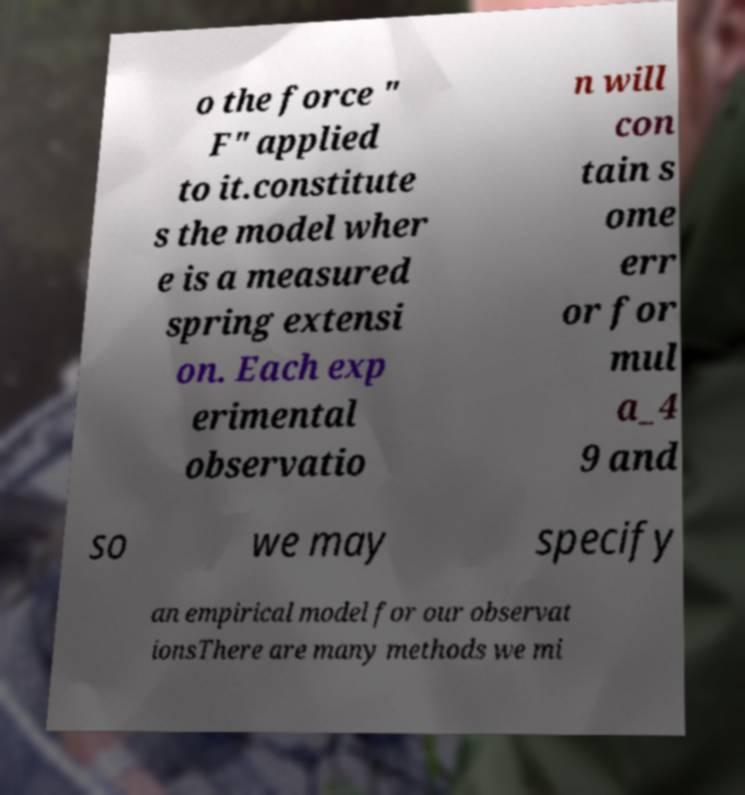There's text embedded in this image that I need extracted. Can you transcribe it verbatim? o the force " F" applied to it.constitute s the model wher e is a measured spring extensi on. Each exp erimental observatio n will con tain s ome err or for mul a_4 9 and so we may specify an empirical model for our observat ionsThere are many methods we mi 